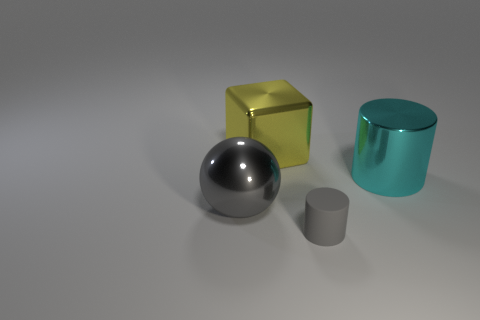Is there any other thing that is made of the same material as the small gray thing?
Give a very brief answer. No. The gray object in front of the large shiny thing that is to the left of the shiny cube is what shape?
Make the answer very short. Cylinder. Is the small thing the same color as the shiny block?
Your answer should be very brief. No. What number of purple things are big metallic balls or cubes?
Your answer should be compact. 0. Are there any big shiny balls on the right side of the metallic block?
Provide a short and direct response. No. The cyan object is what size?
Ensure brevity in your answer.  Large. There is a cyan shiny object that is the same shape as the rubber object; what is its size?
Provide a short and direct response. Large. How many yellow shiny things are to the left of the gray object on the left side of the yellow shiny cube?
Your answer should be compact. 0. Is the large thing left of the large cube made of the same material as the cylinder in front of the large gray metallic thing?
Offer a terse response. No. How many other tiny objects are the same shape as the cyan thing?
Offer a very short reply. 1. 